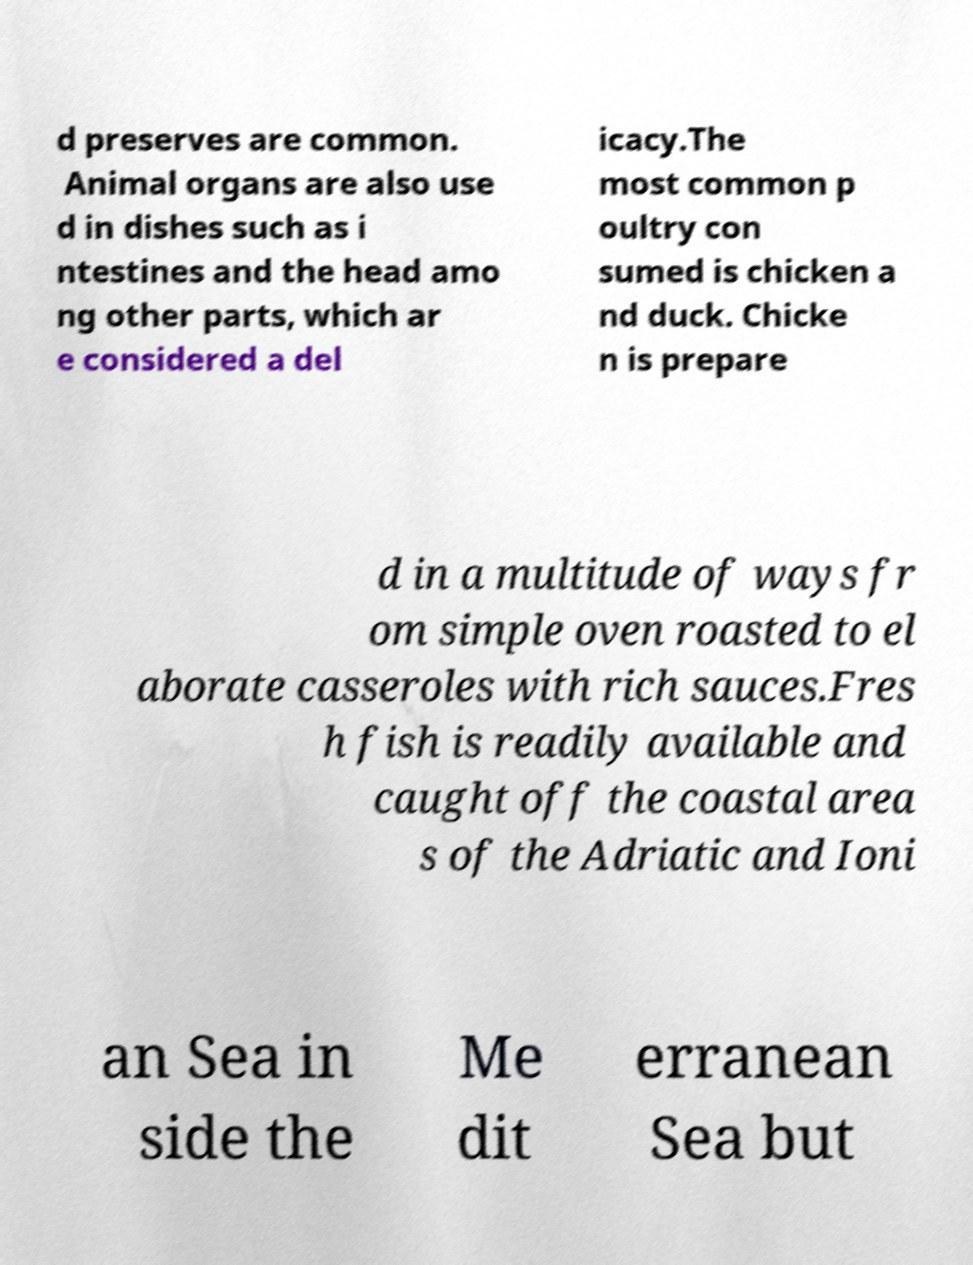Could you assist in decoding the text presented in this image and type it out clearly? d preserves are common. Animal organs are also use d in dishes such as i ntestines and the head amo ng other parts, which ar e considered a del icacy.The most common p oultry con sumed is chicken a nd duck. Chicke n is prepare d in a multitude of ways fr om simple oven roasted to el aborate casseroles with rich sauces.Fres h fish is readily available and caught off the coastal area s of the Adriatic and Ioni an Sea in side the Me dit erranean Sea but 